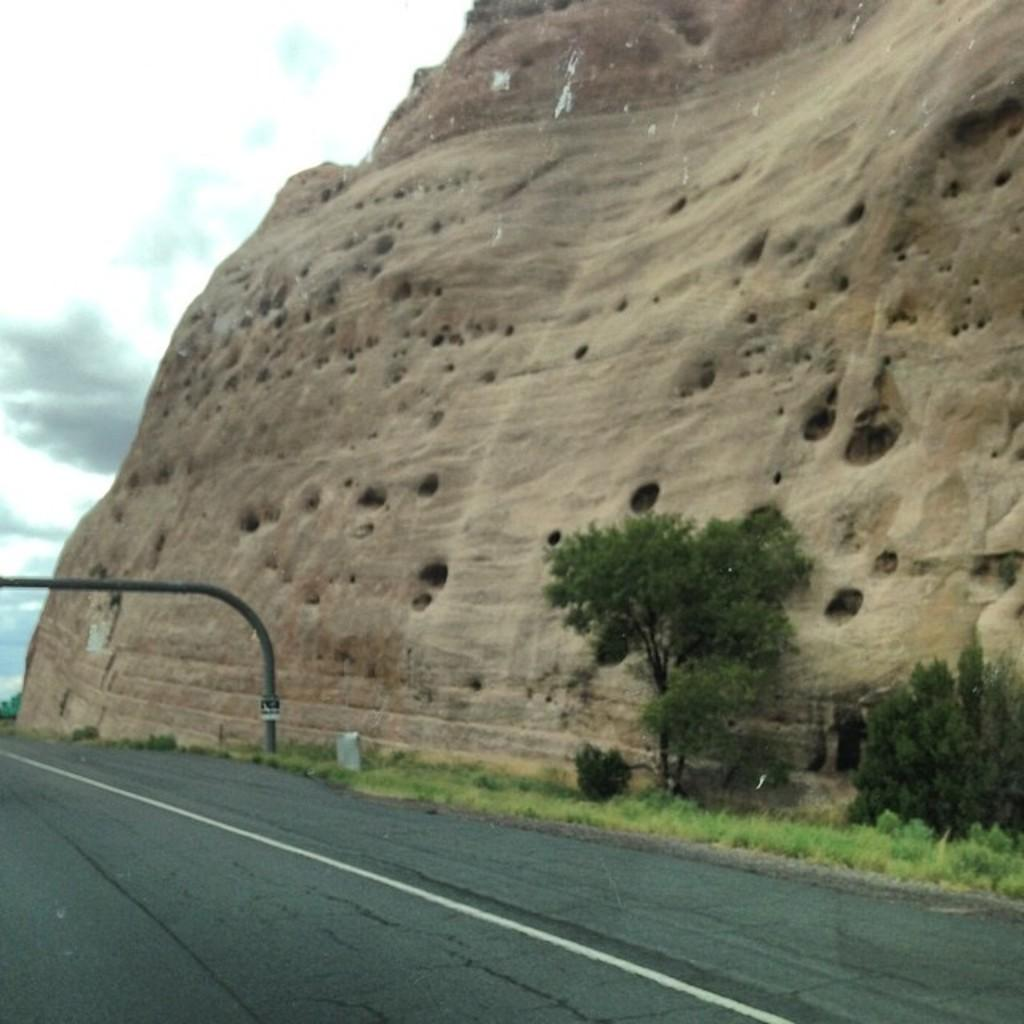What type of surface can be seen in the image? There is a road in the image. What type of vegetation is present in the image? There is grass and trees in the image. What object can be seen sticking up in the image? There is a rod in the image. What type of natural formation is present in the image? There is a rock in the image. What is visible in the background of the image? The sky is visible in the background of the image. What can be seen in the sky in the image? There are clouds in the sky. What type of cake is being served at the event in the image? There is no event or cake present in the image. What items are on the list that can be seen in the image? There is no list present in the image. 